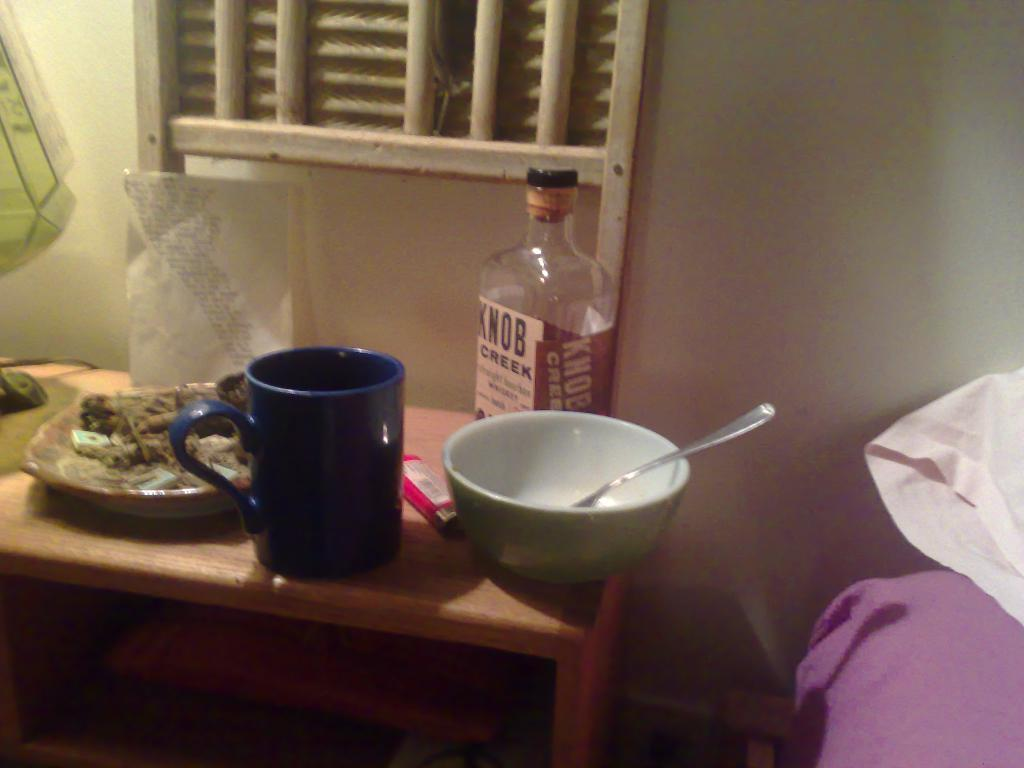<image>
Write a terse but informative summary of the picture. Empty bowl next to a bottle of Knob Creek. 